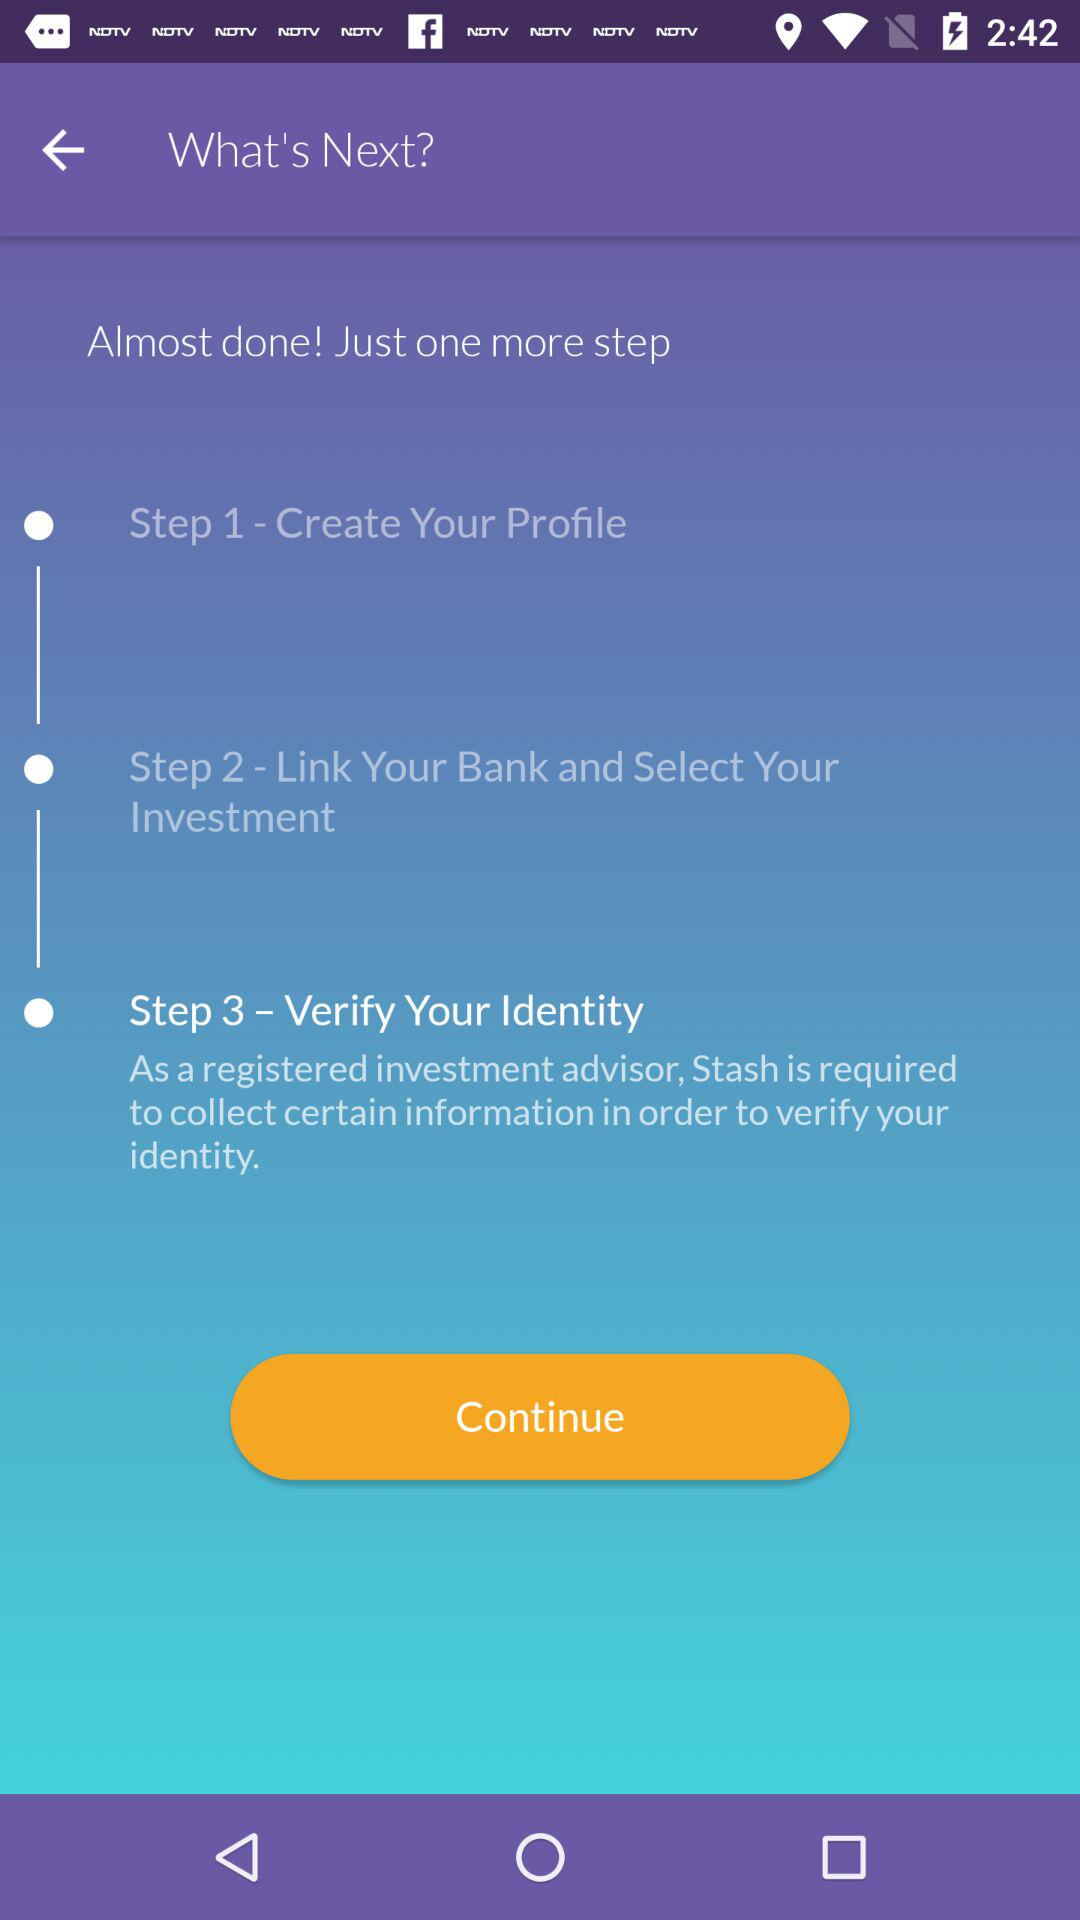How many steps are there in the process?
Answer the question using a single word or phrase. 3 